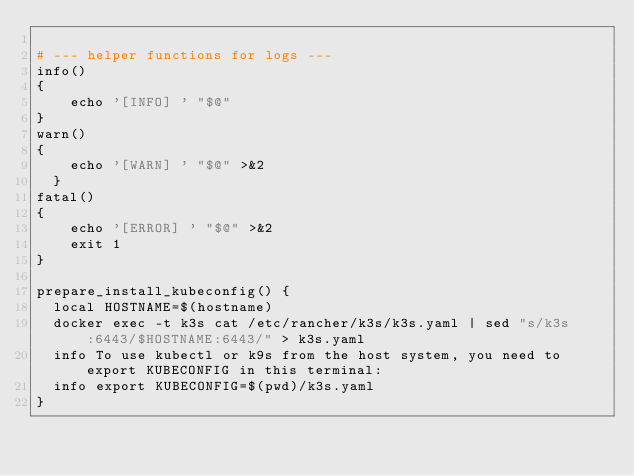<code> <loc_0><loc_0><loc_500><loc_500><_Bash_>
# --- helper functions for logs ---
info()
{
    echo '[INFO] ' "$@"
}
warn()
{
    echo '[WARN] ' "$@" >&2
  }
fatal()
{
    echo '[ERROR] ' "$@" >&2
    exit 1
}

prepare_install_kubeconfig() {
  local HOSTNAME=$(hostname)
  docker exec -t k3s cat /etc/rancher/k3s/k3s.yaml | sed "s/k3s:6443/$HOSTNAME:6443/" > k3s.yaml
  info To use kubectl or k9s from the host system, you need to export KUBECONFIG in this terminal:
  info export KUBECONFIG=$(pwd)/k3s.yaml
}
</code> 